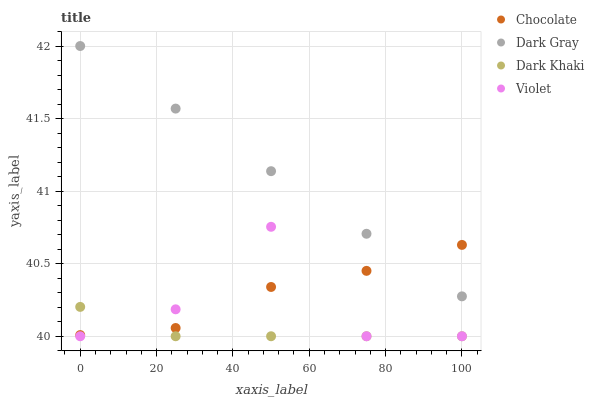Does Dark Khaki have the minimum area under the curve?
Answer yes or no. Yes. Does Dark Gray have the maximum area under the curve?
Answer yes or no. Yes. Does Violet have the minimum area under the curve?
Answer yes or no. No. Does Violet have the maximum area under the curve?
Answer yes or no. No. Is Dark Gray the smoothest?
Answer yes or no. Yes. Is Violet the roughest?
Answer yes or no. Yes. Is Dark Khaki the smoothest?
Answer yes or no. No. Is Dark Khaki the roughest?
Answer yes or no. No. Does Dark Khaki have the lowest value?
Answer yes or no. Yes. Does Chocolate have the lowest value?
Answer yes or no. No. Does Dark Gray have the highest value?
Answer yes or no. Yes. Does Violet have the highest value?
Answer yes or no. No. Is Dark Khaki less than Dark Gray?
Answer yes or no. Yes. Is Dark Gray greater than Dark Khaki?
Answer yes or no. Yes. Does Chocolate intersect Dark Gray?
Answer yes or no. Yes. Is Chocolate less than Dark Gray?
Answer yes or no. No. Is Chocolate greater than Dark Gray?
Answer yes or no. No. Does Dark Khaki intersect Dark Gray?
Answer yes or no. No. 